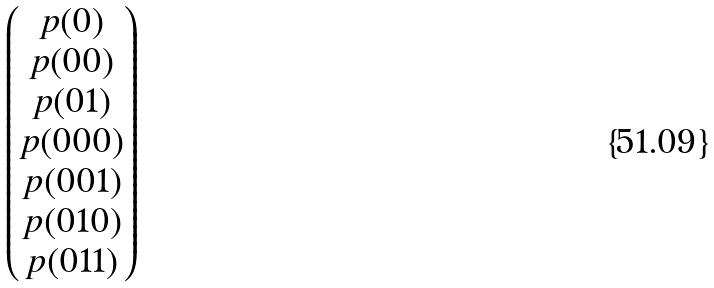Convert formula to latex. <formula><loc_0><loc_0><loc_500><loc_500>\begin{pmatrix} p ( 0 ) \\ p ( 0 0 ) \\ p ( 0 1 ) \\ p ( 0 0 0 ) \\ p ( 0 0 1 ) \\ p ( 0 1 0 ) \\ p ( 0 1 1 ) \end{pmatrix}</formula> 